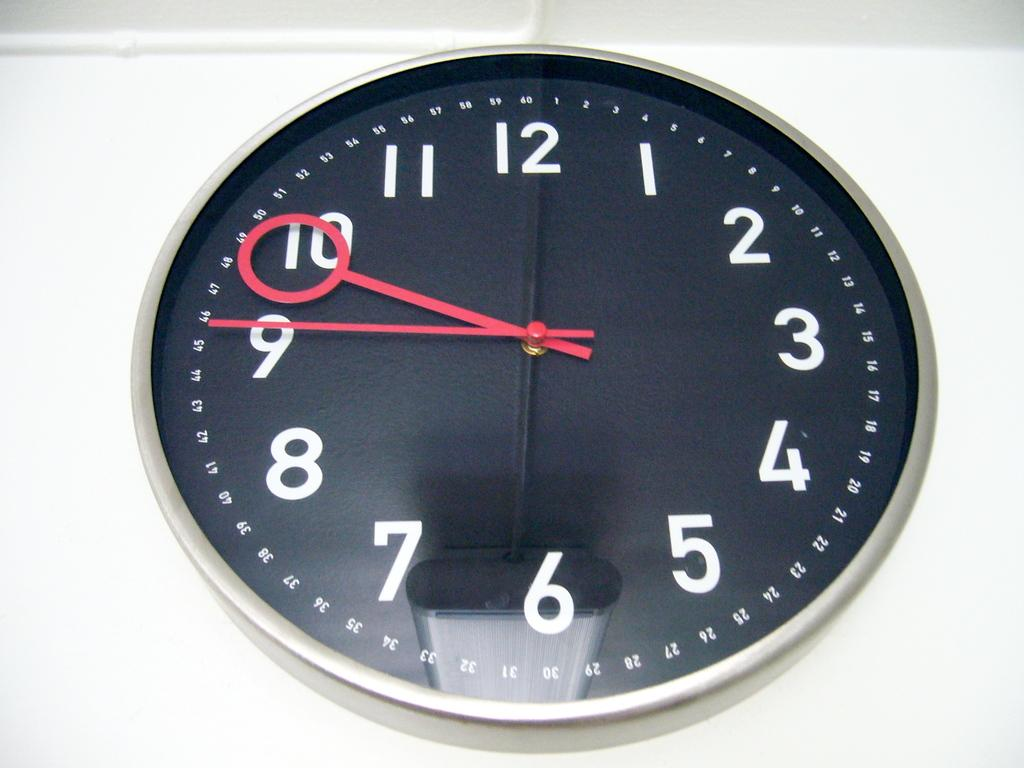<image>
Relay a brief, clear account of the picture shown. A black and white round clock that shows it to be 9:47. 